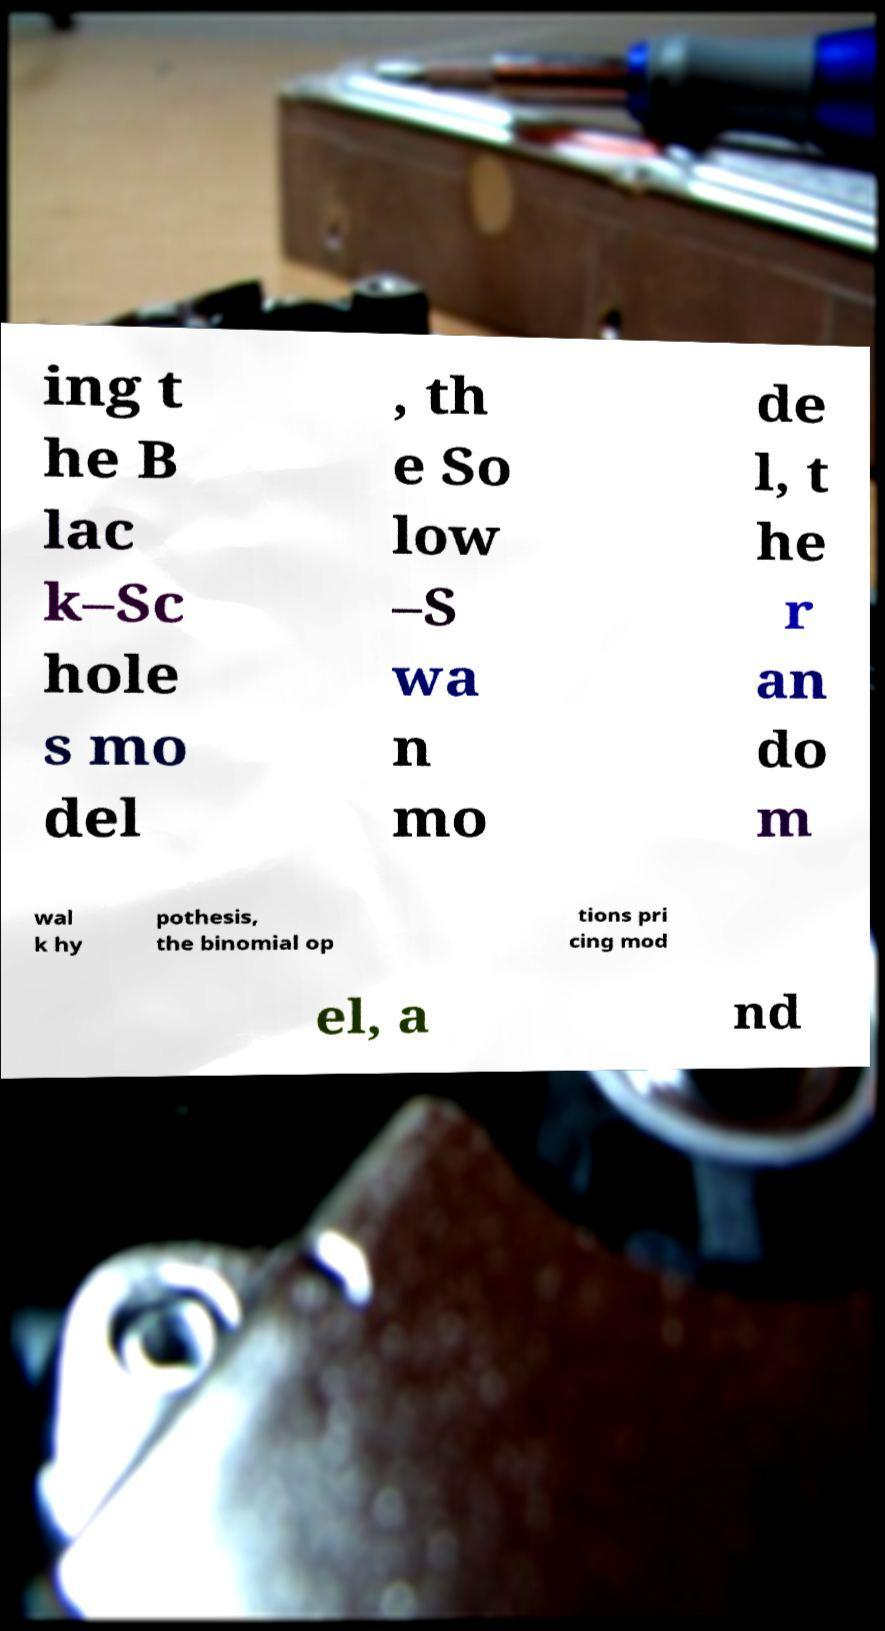Can you read and provide the text displayed in the image?This photo seems to have some interesting text. Can you extract and type it out for me? ing t he B lac k–Sc hole s mo del , th e So low –S wa n mo de l, t he r an do m wal k hy pothesis, the binomial op tions pri cing mod el, a nd 